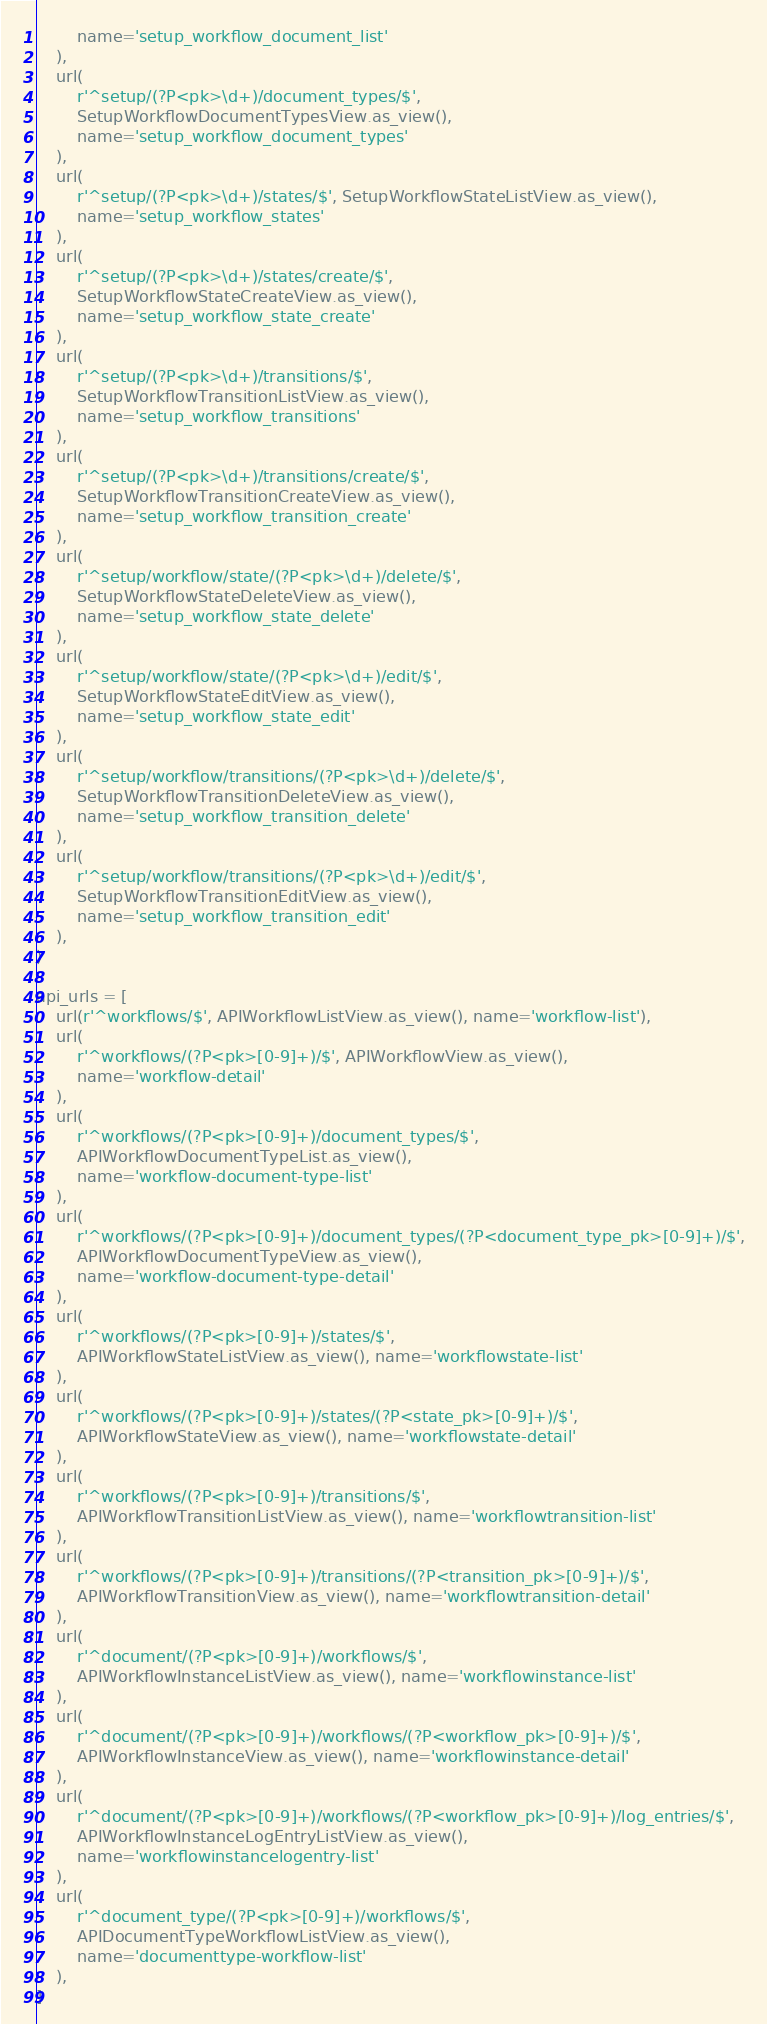<code> <loc_0><loc_0><loc_500><loc_500><_Python_>        name='setup_workflow_document_list'
    ),
    url(
        r'^setup/(?P<pk>\d+)/document_types/$',
        SetupWorkflowDocumentTypesView.as_view(),
        name='setup_workflow_document_types'
    ),
    url(
        r'^setup/(?P<pk>\d+)/states/$', SetupWorkflowStateListView.as_view(),
        name='setup_workflow_states'
    ),
    url(
        r'^setup/(?P<pk>\d+)/states/create/$',
        SetupWorkflowStateCreateView.as_view(),
        name='setup_workflow_state_create'
    ),
    url(
        r'^setup/(?P<pk>\d+)/transitions/$',
        SetupWorkflowTransitionListView.as_view(),
        name='setup_workflow_transitions'
    ),
    url(
        r'^setup/(?P<pk>\d+)/transitions/create/$',
        SetupWorkflowTransitionCreateView.as_view(),
        name='setup_workflow_transition_create'
    ),
    url(
        r'^setup/workflow/state/(?P<pk>\d+)/delete/$',
        SetupWorkflowStateDeleteView.as_view(),
        name='setup_workflow_state_delete'
    ),
    url(
        r'^setup/workflow/state/(?P<pk>\d+)/edit/$',
        SetupWorkflowStateEditView.as_view(),
        name='setup_workflow_state_edit'
    ),
    url(
        r'^setup/workflow/transitions/(?P<pk>\d+)/delete/$',
        SetupWorkflowTransitionDeleteView.as_view(),
        name='setup_workflow_transition_delete'
    ),
    url(
        r'^setup/workflow/transitions/(?P<pk>\d+)/edit/$',
        SetupWorkflowTransitionEditView.as_view(),
        name='setup_workflow_transition_edit'
    ),
)

api_urls = [
    url(r'^workflows/$', APIWorkflowListView.as_view(), name='workflow-list'),
    url(
        r'^workflows/(?P<pk>[0-9]+)/$', APIWorkflowView.as_view(),
        name='workflow-detail'
    ),
    url(
        r'^workflows/(?P<pk>[0-9]+)/document_types/$',
        APIWorkflowDocumentTypeList.as_view(),
        name='workflow-document-type-list'
    ),
    url(
        r'^workflows/(?P<pk>[0-9]+)/document_types/(?P<document_type_pk>[0-9]+)/$',
        APIWorkflowDocumentTypeView.as_view(),
        name='workflow-document-type-detail'
    ),
    url(
        r'^workflows/(?P<pk>[0-9]+)/states/$',
        APIWorkflowStateListView.as_view(), name='workflowstate-list'
    ),
    url(
        r'^workflows/(?P<pk>[0-9]+)/states/(?P<state_pk>[0-9]+)/$',
        APIWorkflowStateView.as_view(), name='workflowstate-detail'
    ),
    url(
        r'^workflows/(?P<pk>[0-9]+)/transitions/$',
        APIWorkflowTransitionListView.as_view(), name='workflowtransition-list'
    ),
    url(
        r'^workflows/(?P<pk>[0-9]+)/transitions/(?P<transition_pk>[0-9]+)/$',
        APIWorkflowTransitionView.as_view(), name='workflowtransition-detail'
    ),
    url(
        r'^document/(?P<pk>[0-9]+)/workflows/$',
        APIWorkflowInstanceListView.as_view(), name='workflowinstance-list'
    ),
    url(
        r'^document/(?P<pk>[0-9]+)/workflows/(?P<workflow_pk>[0-9]+)/$',
        APIWorkflowInstanceView.as_view(), name='workflowinstance-detail'
    ),
    url(
        r'^document/(?P<pk>[0-9]+)/workflows/(?P<workflow_pk>[0-9]+)/log_entries/$',
        APIWorkflowInstanceLogEntryListView.as_view(),
        name='workflowinstancelogentry-list'
    ),
    url(
        r'^document_type/(?P<pk>[0-9]+)/workflows/$',
        APIDocumentTypeWorkflowListView.as_view(),
        name='documenttype-workflow-list'
    ),
]
</code> 